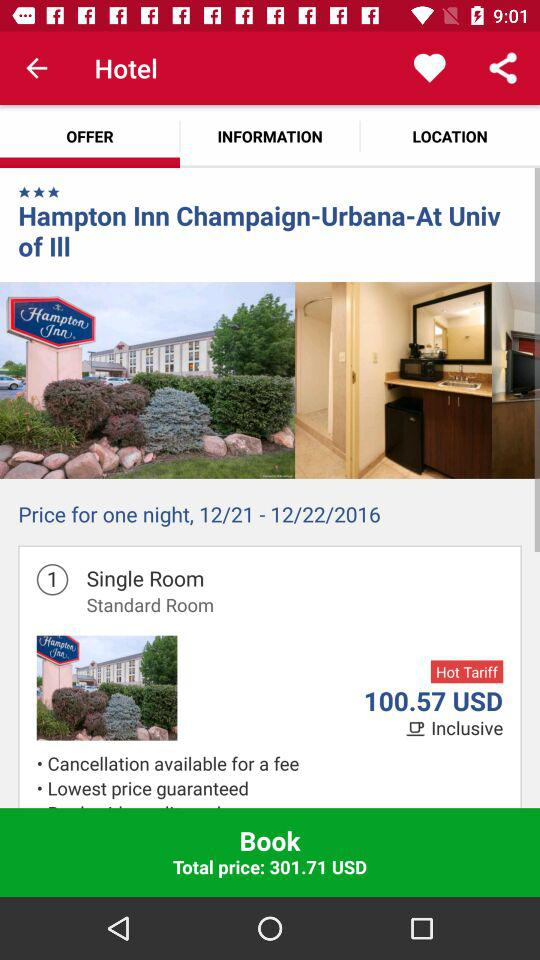What is the total price of the hotel room?
Answer the question using a single word or phrase. 301.71 USD 